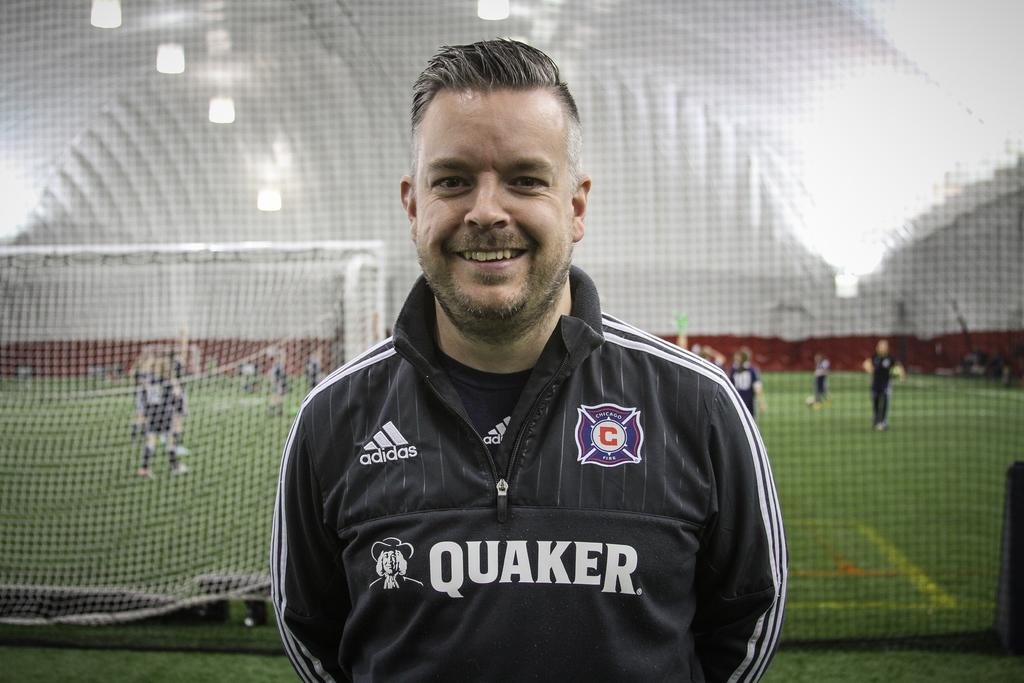<image>
Relay a brief, clear account of the picture shown. A man with an adidas Quaker black jacket on stands in front of a soccer field. 